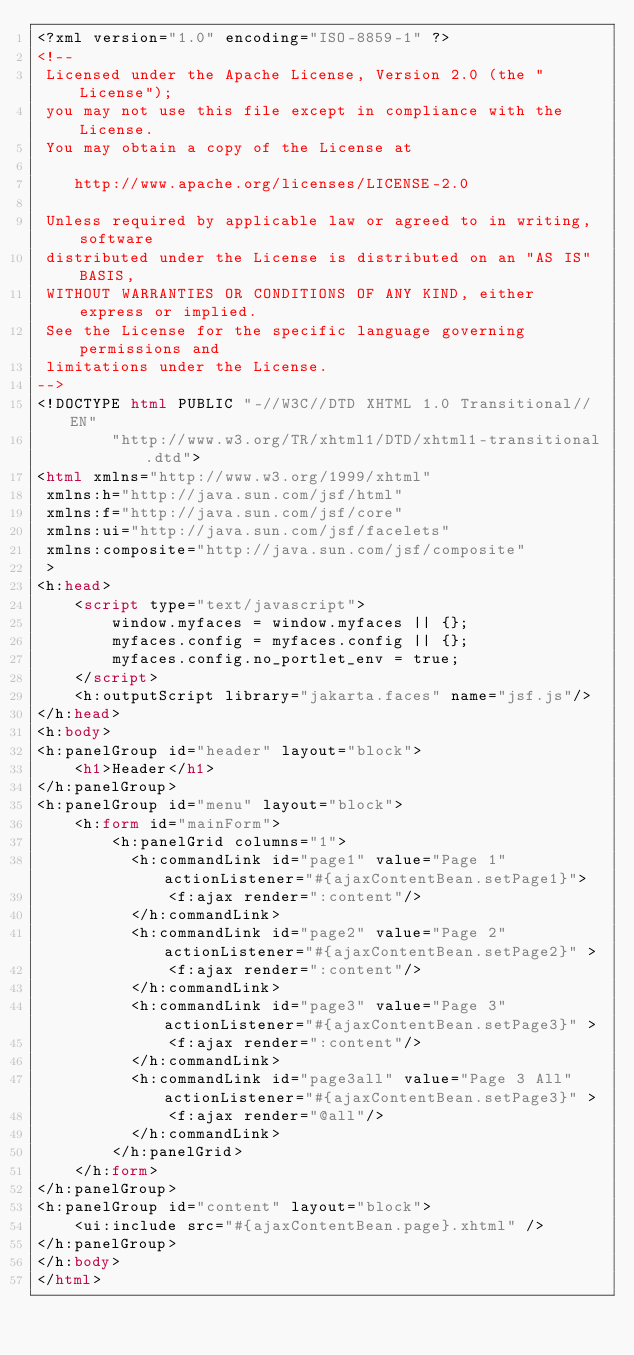Convert code to text. <code><loc_0><loc_0><loc_500><loc_500><_HTML_><?xml version="1.0" encoding="ISO-8859-1" ?>
<!--
 Licensed under the Apache License, Version 2.0 (the "License");
 you may not use this file except in compliance with the License.
 You may obtain a copy of the License at

    http://www.apache.org/licenses/LICENSE-2.0

 Unless required by applicable law or agreed to in writing, software
 distributed under the License is distributed on an "AS IS" BASIS,
 WITHOUT WARRANTIES OR CONDITIONS OF ANY KIND, either express or implied.
 See the License for the specific language governing permissions and
 limitations under the License.
-->
<!DOCTYPE html PUBLIC "-//W3C//DTD XHTML 1.0 Transitional//EN"
        "http://www.w3.org/TR/xhtml1/DTD/xhtml1-transitional.dtd">
<html xmlns="http://www.w3.org/1999/xhtml"
 xmlns:h="http://java.sun.com/jsf/html"
 xmlns:f="http://java.sun.com/jsf/core"
 xmlns:ui="http://java.sun.com/jsf/facelets"
 xmlns:composite="http://java.sun.com/jsf/composite"
 >
<h:head>
    <script type="text/javascript">
        window.myfaces = window.myfaces || {};
        myfaces.config = myfaces.config || {}; 
        myfaces.config.no_portlet_env = true; 
    </script>
    <h:outputScript library="jakarta.faces" name="jsf.js"/>
</h:head>
<h:body>
<h:panelGroup id="header" layout="block">
    <h1>Header</h1>
</h:panelGroup>
<h:panelGroup id="menu" layout="block">
    <h:form id="mainForm">
        <h:panelGrid columns="1">
          <h:commandLink id="page1" value="Page 1" actionListener="#{ajaxContentBean.setPage1}">
              <f:ajax render=":content"/>
          </h:commandLink>
          <h:commandLink id="page2" value="Page 2" actionListener="#{ajaxContentBean.setPage2}" >
              <f:ajax render=":content"/>
          </h:commandLink>
          <h:commandLink id="page3" value="Page 3" actionListener="#{ajaxContentBean.setPage3}" >
              <f:ajax render=":content"/>
          </h:commandLink>
          <h:commandLink id="page3all" value="Page 3 All" actionListener="#{ajaxContentBean.setPage3}" >
              <f:ajax render="@all"/>
          </h:commandLink>
        </h:panelGrid>
    </h:form>
</h:panelGroup>
<h:panelGroup id="content" layout="block">
    <ui:include src="#{ajaxContentBean.page}.xhtml" />
</h:panelGroup>
</h:body>
</html>
</code> 